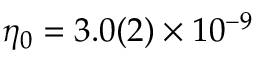<formula> <loc_0><loc_0><loc_500><loc_500>\eta _ { 0 } = 3 . 0 ( 2 ) \times 1 0 ^ { - 9 }</formula> 